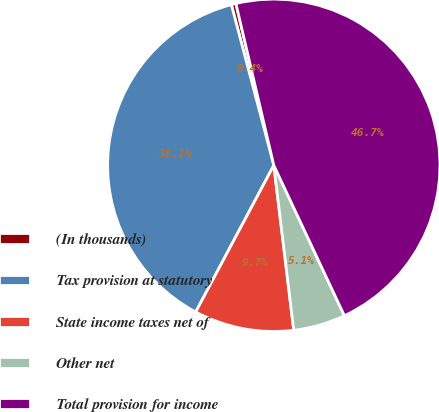<chart> <loc_0><loc_0><loc_500><loc_500><pie_chart><fcel>(In thousands)<fcel>Tax provision at statutory<fcel>State income taxes net of<fcel>Other net<fcel>Total provision for income<nl><fcel>0.45%<fcel>38.1%<fcel>9.7%<fcel>5.07%<fcel>46.68%<nl></chart> 